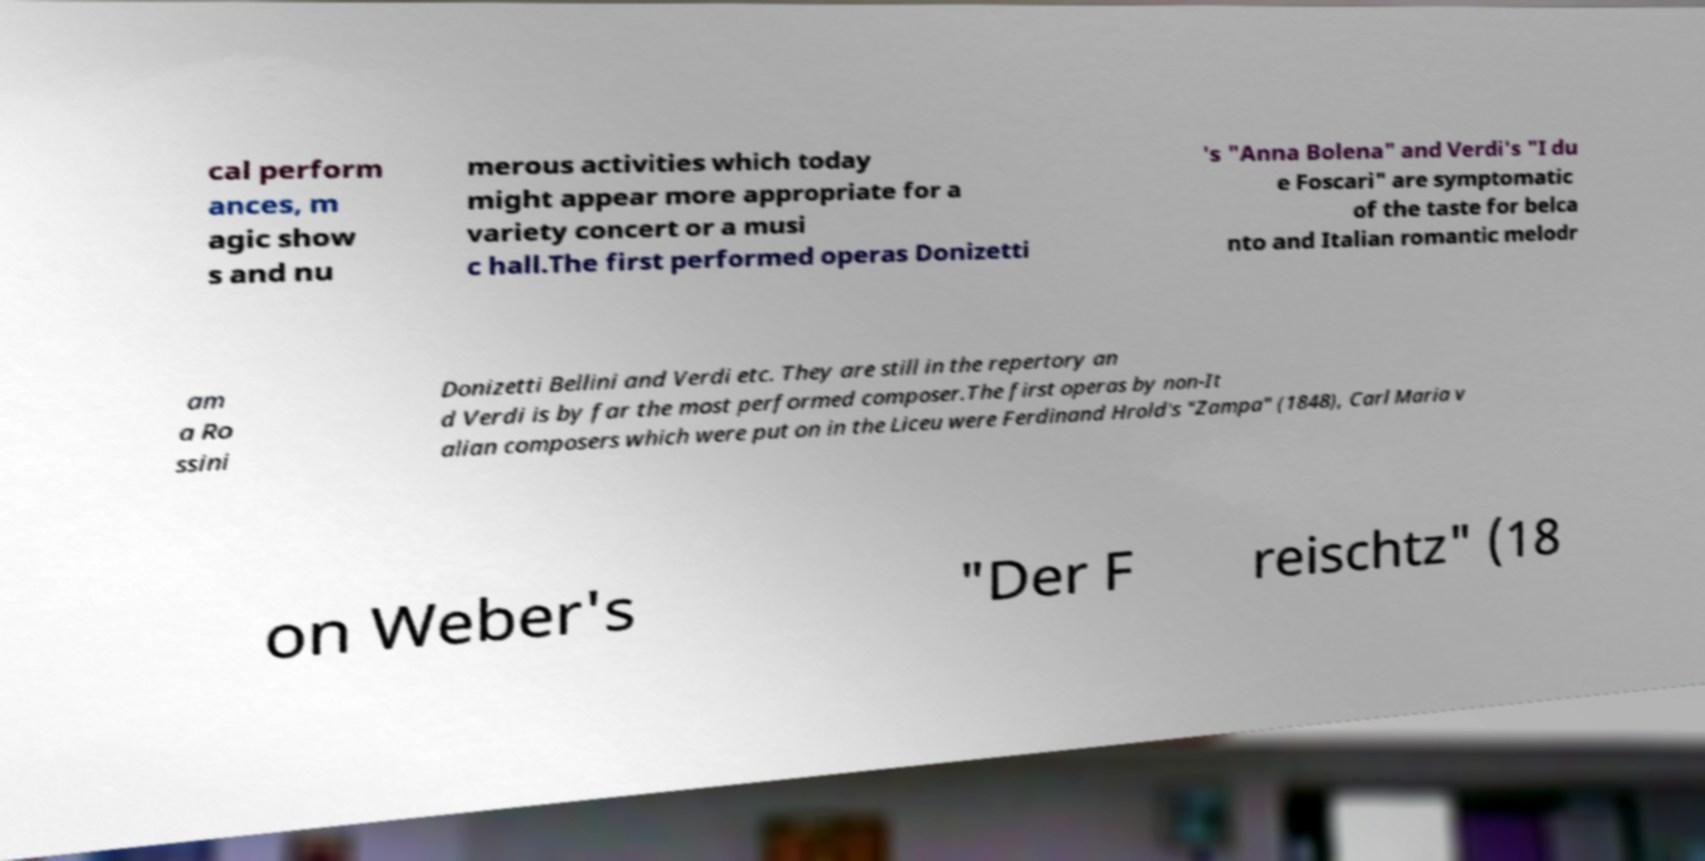Please read and relay the text visible in this image. What does it say? cal perform ances, m agic show s and nu merous activities which today might appear more appropriate for a variety concert or a musi c hall.The first performed operas Donizetti 's "Anna Bolena" and Verdi's "I du e Foscari" are symptomatic of the taste for belca nto and Italian romantic melodr am a Ro ssini Donizetti Bellini and Verdi etc. They are still in the repertory an d Verdi is by far the most performed composer.The first operas by non-It alian composers which were put on in the Liceu were Ferdinand Hrold's "Zampa" (1848), Carl Maria v on Weber's "Der F reischtz" (18 